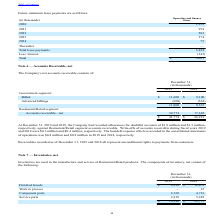From Par Technology's financial document, How much allowances for doubtful accounts was recorded against Restaurant/Retail segment accounts receivable at December 31, 2019 and 2018 respectively? The document shows two values: $1.8 million and $1.3 million. From the document: "lowances for doubtful accounts of $1.8 million and $1.3 million, respectively, against Restaurant/Retail segment accounts receivable. Write-offs of ac..." Also, How much was the Write-offs of accounts receivable during fiscal years 2019 and 2018 respectively? The document shows two values: $0.3 million and $0.4 million. From the document: "g fiscal years 2019 and 2018 were $0.3 million and $0.4 million, respectively. The bad debt expense which is recorded in the consolidated statements o..." Also, How much bad debt expense was recorded in 2019 and 2018 respectively? The document shows two values: $0.8 million and $0.8 million. From the document: "d in the consolidated statements of operations was $0.8 million and $0.8 million in 2019 and 2018, respectively. d in the consolidated statements of o..." Also, can you calculate: What is the change in Government segment: Billed between December 31, 2018 and 2019? Based on the calculation: 11,608-9,100, the result is 2508 (in thousands). This is based on the information: "Billed $ 11,608 $ 9,100 Billed $ 11,608 $ 9,100..." The key data points involved are: 11,608, 9,100. Also, can you calculate: What is the change in Government segment: Advanced billings between December 31, 2018 and 2019? Based on the calculation: 608-563, the result is 45 (in thousands). This is based on the information: "Advanced billings (608) (563) Advanced billings (608) (563)..." The key data points involved are: 563, 608. Also, can you calculate: What is the average Government segment: Billed for December 31, 2018 and 2019? To answer this question, I need to perform calculations using the financial data. The calculation is: (11,608+9,100) / 2, which equals 10354 (in thousands). This is based on the information: "Billed $ 11,608 $ 9,100 Billed $ 11,608 $ 9,100..." The key data points involved are: 11,608, 9,100. 